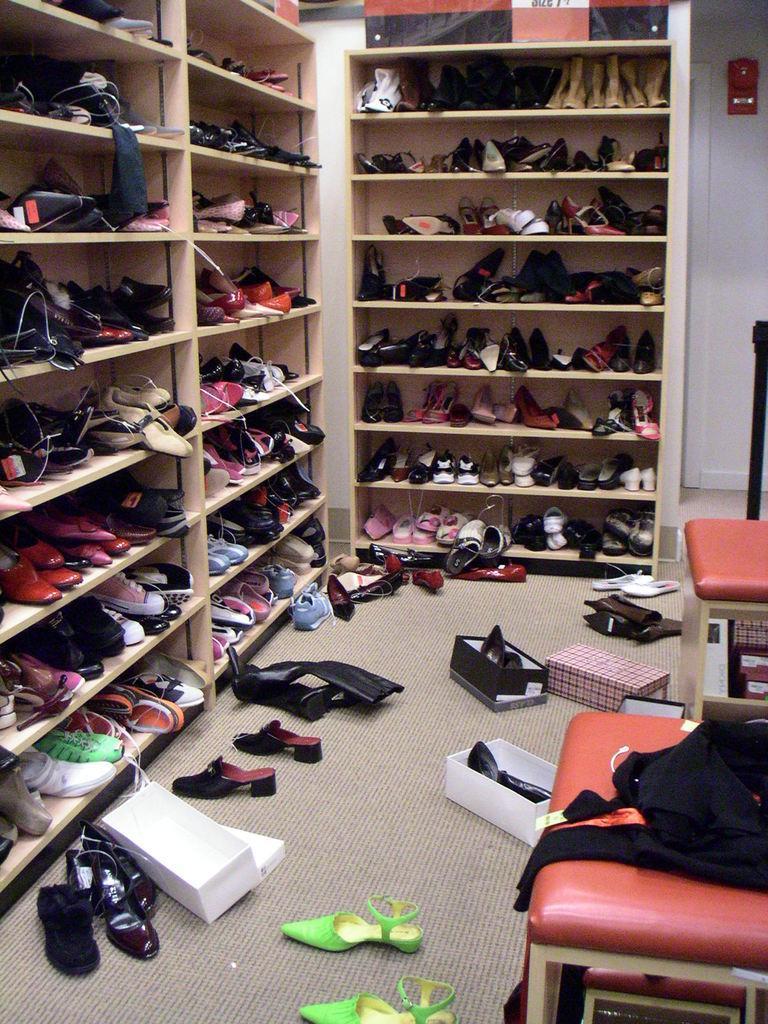In one or two sentences, can you explain what this image depicts? In the bottom right corner of the image there are some chairs. In the middle of the image there are some boxes and footwear. At the top of the image there are some footwear in the cupboards. 